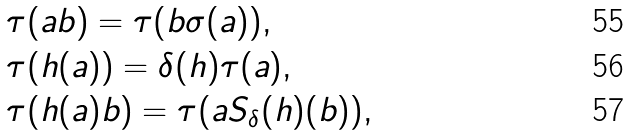Convert formula to latex. <formula><loc_0><loc_0><loc_500><loc_500>& \tau ( a b ) = \tau ( b \sigma ( a ) ) , \\ & \tau ( h ( a ) ) = \delta ( h ) \tau ( a ) , \\ & \tau ( h ( a ) b ) = \tau ( a S _ { \delta } ( h ) ( b ) ) ,</formula> 